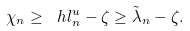<formula> <loc_0><loc_0><loc_500><loc_500>\chi _ { n } \geq \ h l _ { n } ^ { u } - \zeta \geq \tilde { \lambda } _ { n } - \zeta .</formula> 